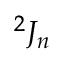Convert formula to latex. <formula><loc_0><loc_0><loc_500><loc_500>{ } ^ { 2 } J _ { n }</formula> 